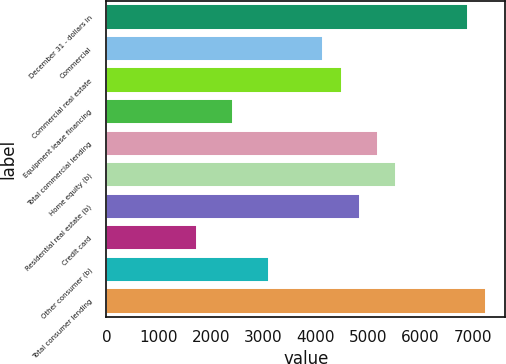Convert chart. <chart><loc_0><loc_0><loc_500><loc_500><bar_chart><fcel>December 31 - dollars in<fcel>Commercial<fcel>Commercial real estate<fcel>Equipment lease financing<fcel>Total commercial lending<fcel>Home equity (b)<fcel>Residential real estate (b)<fcel>Credit card<fcel>Other consumer (b)<fcel>Total consumer lending<nl><fcel>6913.78<fcel>4148.34<fcel>4494.02<fcel>2419.94<fcel>5185.38<fcel>5531.06<fcel>4839.7<fcel>1728.58<fcel>3111.3<fcel>7259.46<nl></chart> 